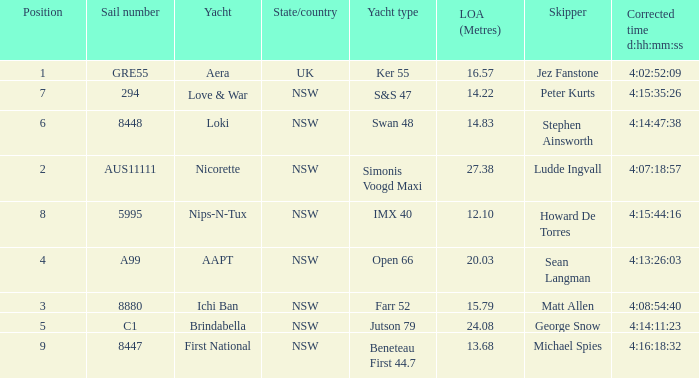What is the ranking for NSW open 66 racing boat.  4.0. 